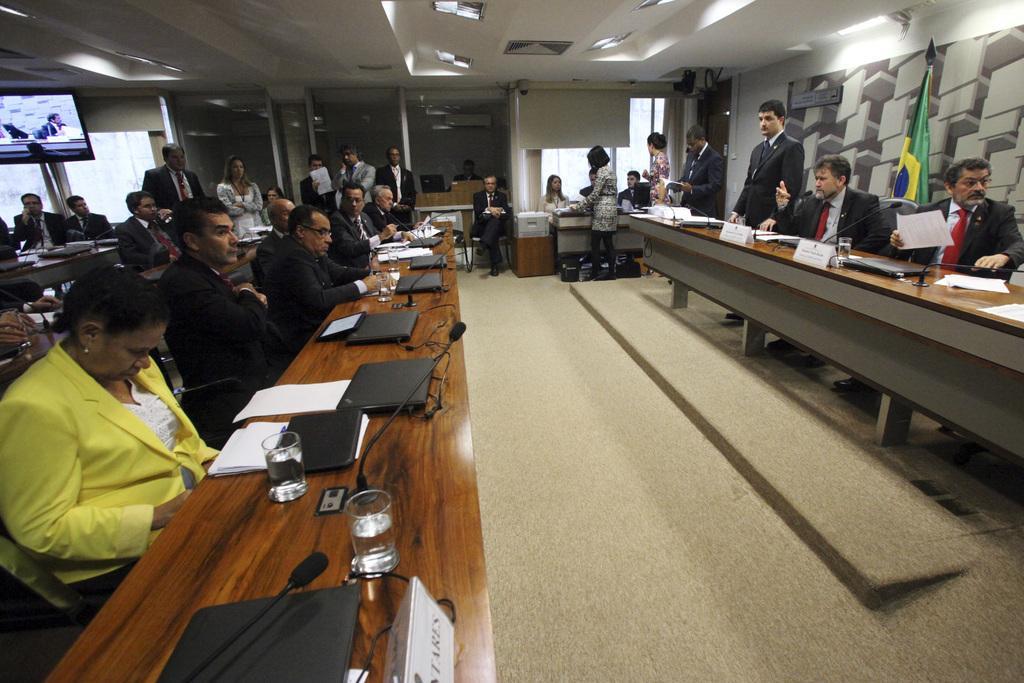Describe this image in one or two sentences. In this image, In the left side there is a table in brown color and on that table there are some laptops in black color and there are some glasses on the table, There are some people sitting on the chairs and in the middle there is a floor in gray color and in the right side there are some people sitting on the chairs around the table, In the top there is a white color roof and there are some lights on the roof. 